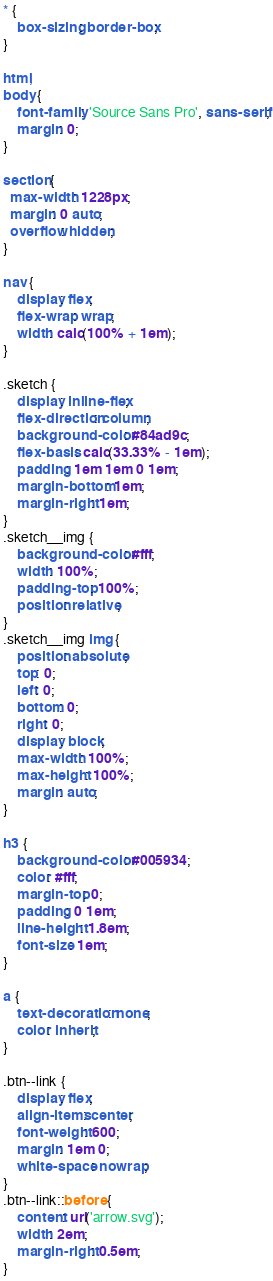Convert code to text. <code><loc_0><loc_0><loc_500><loc_500><_CSS_>* {
	box-sizing: border-box;
}

html,
body {
	font-family: 'Source Sans Pro', sans-serif;
	margin: 0;
}

section {
  max-width: 1228px;
  margin: 0 auto;
  overflow: hidden;
}

nav {
	display: flex;
	flex-wrap: wrap;
	width: calc(100% + 1em);
}

.sketch {
	display: inline-flex;
	flex-direction: column;
	background-color: #84ad9c;
	flex-basis: calc(33.33% - 1em);
	padding: 1em 1em 0 1em;
	margin-bottom: 1em;
	margin-right: 1em;
}
.sketch__img {
	background-color: #fff;
	width: 100%;
	padding-top: 100%;
	position: relative;
}
.sketch__img img {
	position: absolute;
	top: 0;
	left: 0;
	bottom: 0;
	right: 0;
	display: block;
	max-width: 100%;
	max-height: 100%;
	margin: auto;
}

h3 {
	background-color: #005934;
	color: #fff;
	margin-top: 0;
	padding: 0 1em;
	line-height: 1.8em;
	font-size: 1em;
}

a {
	text-decoration: none;
	color: inherit;
}

.btn--link {
	display: flex;
	align-items: center;
	font-weight: 600;
	margin: 1em 0;
	white-space: nowrap;
}
.btn--link::before {
	content: url('arrow.svg');
	width: 2em;
	margin-right: 0.5em;
}
</code> 